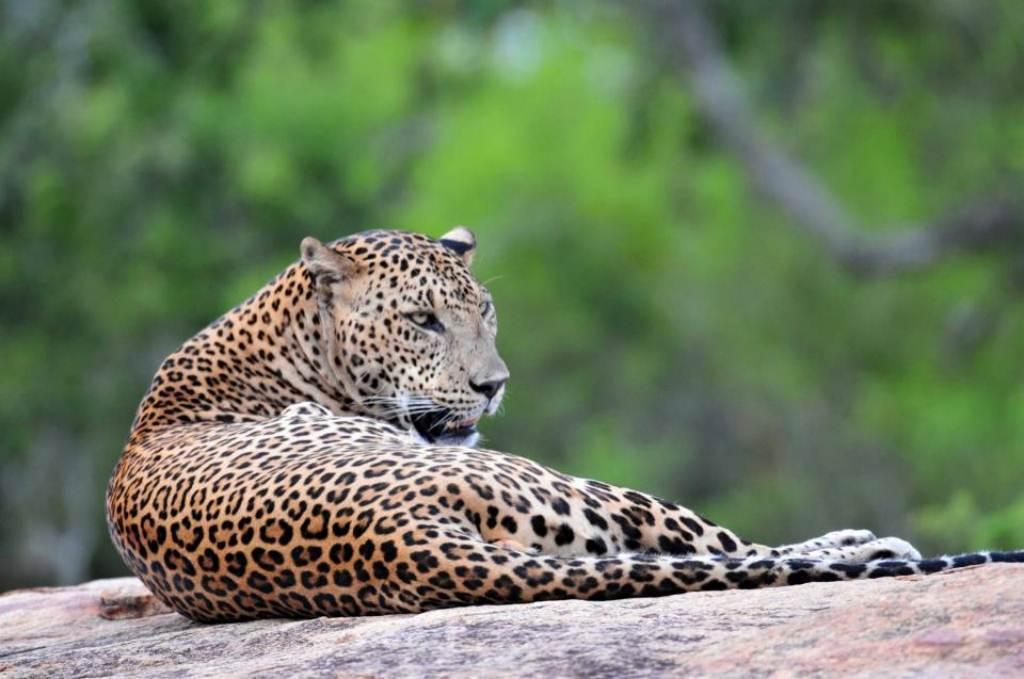What animal is the main subject of the image? There is a leopard in the image. How would you describe the background of the image? The background of the image is blurred. What type of environment can be seen in the background? There is greenery visible in the background. Can you tell me how many times the leopard exchanges its spots in the image? Leopards do not exchange their spots; their spots are a natural part of their fur pattern. 